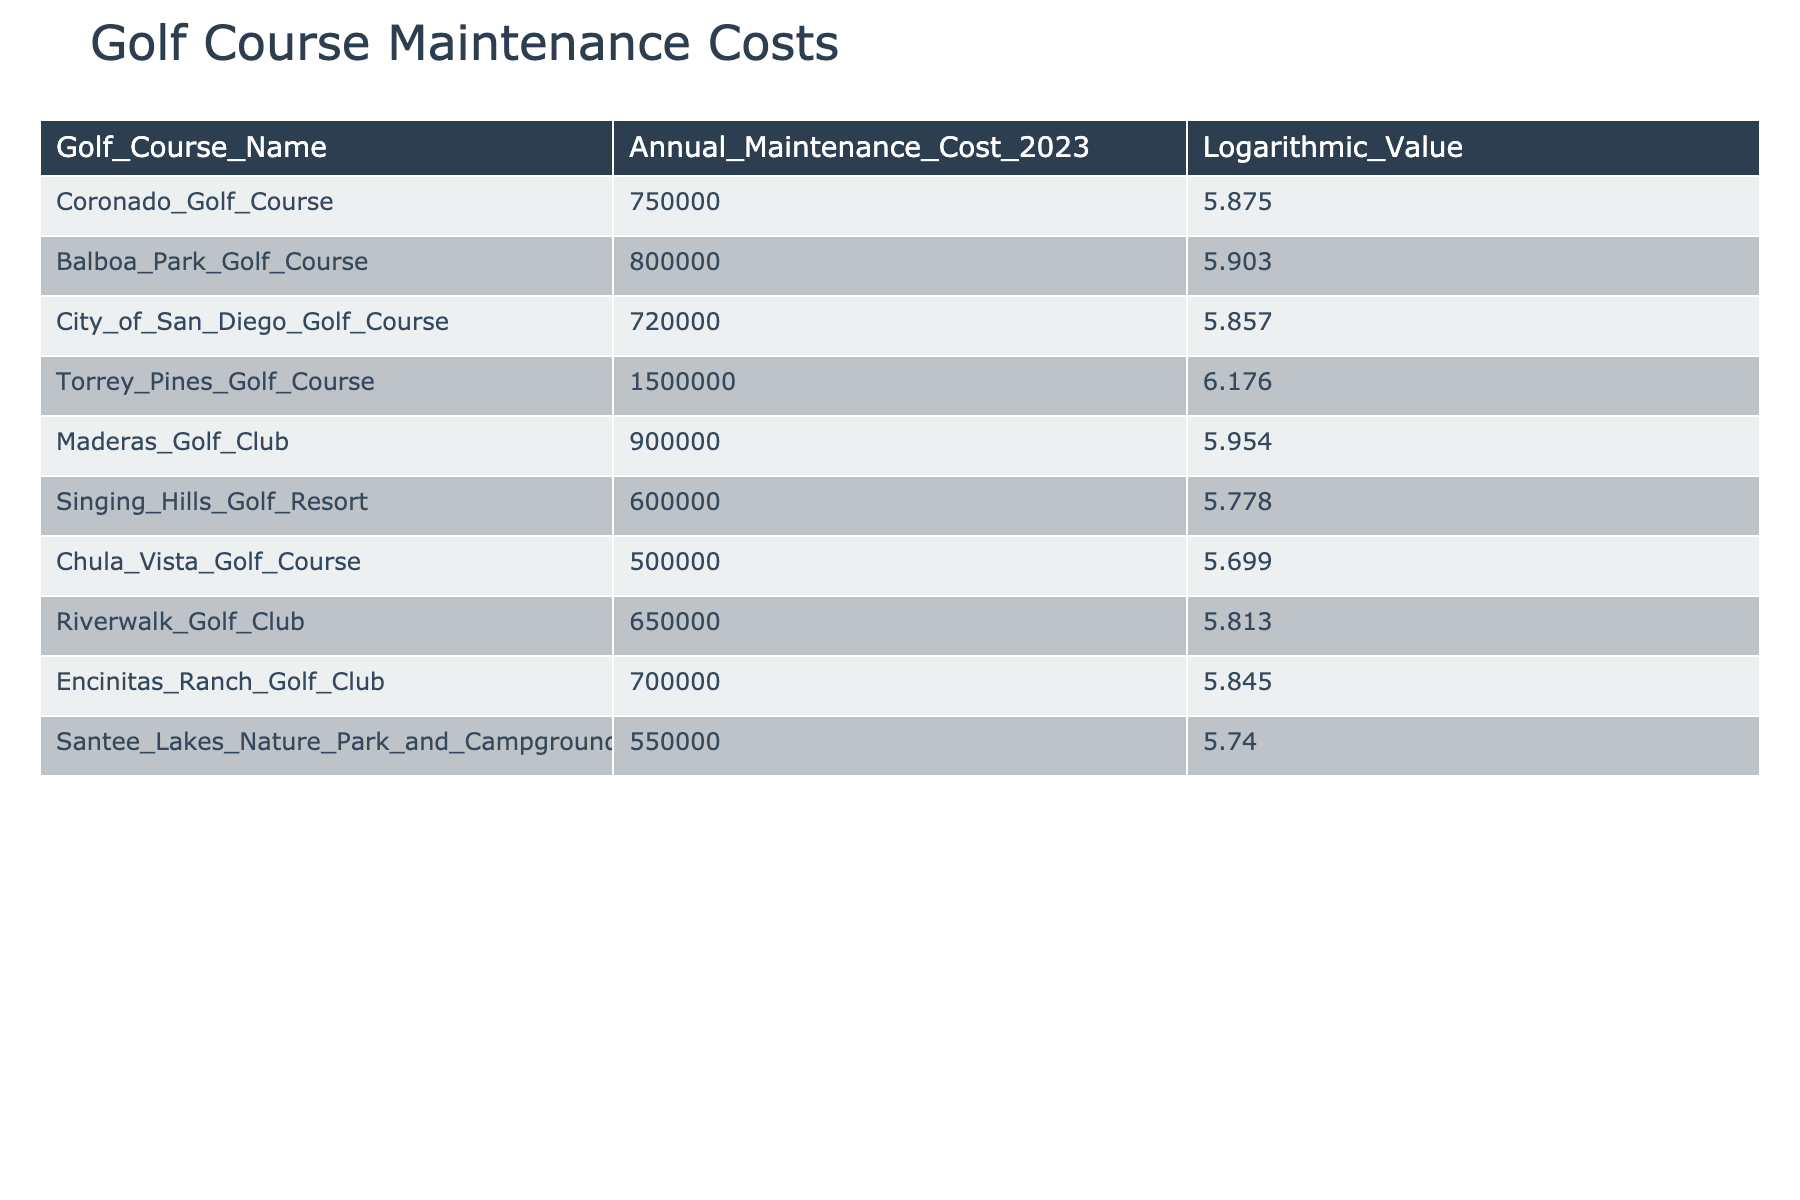What is the annual maintenance cost of the Coronado Golf Course? The annual maintenance cost listed for the Coronado Golf Course in the table is directly visible.
Answer: 750000 Which golf course has the highest annual maintenance cost? The table lists all courses' annual maintenance costs, and by scanning through the values, Torrey Pines Golf Course has the highest cost at 1500000.
Answer: 1500000 Is the maintenance cost of Balboa Park Golf Course higher than that of Singing Hills Golf Resort? Comparing the two values from the table, Balboa Park Golf Course has an annual cost of 800000, while Singing Hills Golf Resort has a cost of 600000. Since 800000 is greater than 600000, the statement is true.
Answer: Yes What is the average annual maintenance cost of all golf courses listed? To find the average, sum all the annual costs: 750000 + 800000 + 720000 + 1500000 + 900000 + 600000 + 500000 + 650000 + 700000 + 550000 = 9000000. Divide by the number of courses (10) to get the average: 9000000 / 10 = 900000.
Answer: 900000 Is the logarithmic value of Maderas Golf Club greater than that of Encinitas Ranch Golf Club? The logarithmic values from the table show Maderas Golf Club's value is 5.954 and Encinitas Ranch Golf Club's value is 5.845. Since 5.954 is greater than 5.845, the statement is true.
Answer: Yes What is the difference between the maintenance costs of Torrey Pines Golf Course and Chula Vista Golf Course? Torrey Pines Golf Course has a cost of 1500000, and Chula Vista Golf Course has a cost of 500000. The difference is calculated by subtracting the lower cost from the higher cost: 1500000 - 500000 = 1000000.
Answer: 1000000 Which courses have maintenance costs lower than 600000? Scanning through the table, the courses with costs lower than 600000 are the Chula Vista Golf Course (500000) and Singing Hills Golf Resort (600000). However, Singing Hills does not qualify as it is not lower, so only Chula Vista Golf Course fits.
Answer: Chula Vista Golf Course What is the total annual maintenance cost of all golf courses with costs above 700000? The courses with costs above 700000 are Coronado Golf Course (750000), Balboa Park Golf Course (800000), Torrey Pines Golf Course (1500000), Maderas Golf Club (900000), and Encinitas Ranch Golf Club (700000). Summing these gives: 750000 + 800000 + 1500000 + 900000 = 3650000.
Answer: 3650000 